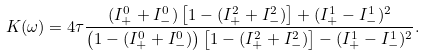<formula> <loc_0><loc_0><loc_500><loc_500>K ( \omega ) = 4 \tau \frac { ( I ^ { 0 } _ { + } + I ^ { 0 } _ { - } ) \left [ 1 - ( I ^ { 2 } _ { + } + I ^ { 2 } _ { - } ) \right ] + ( I ^ { 1 } _ { + } - I ^ { 1 } _ { - } ) ^ { 2 } } { \left ( 1 - ( I ^ { 0 } _ { + } + I ^ { 0 } _ { - } ) \right ) \left [ 1 - ( I ^ { 2 } _ { + } + I ^ { 2 } _ { - } ) \right ] - ( I ^ { 1 } _ { + } - I ^ { 1 } _ { - } ) ^ { 2 } } .</formula> 